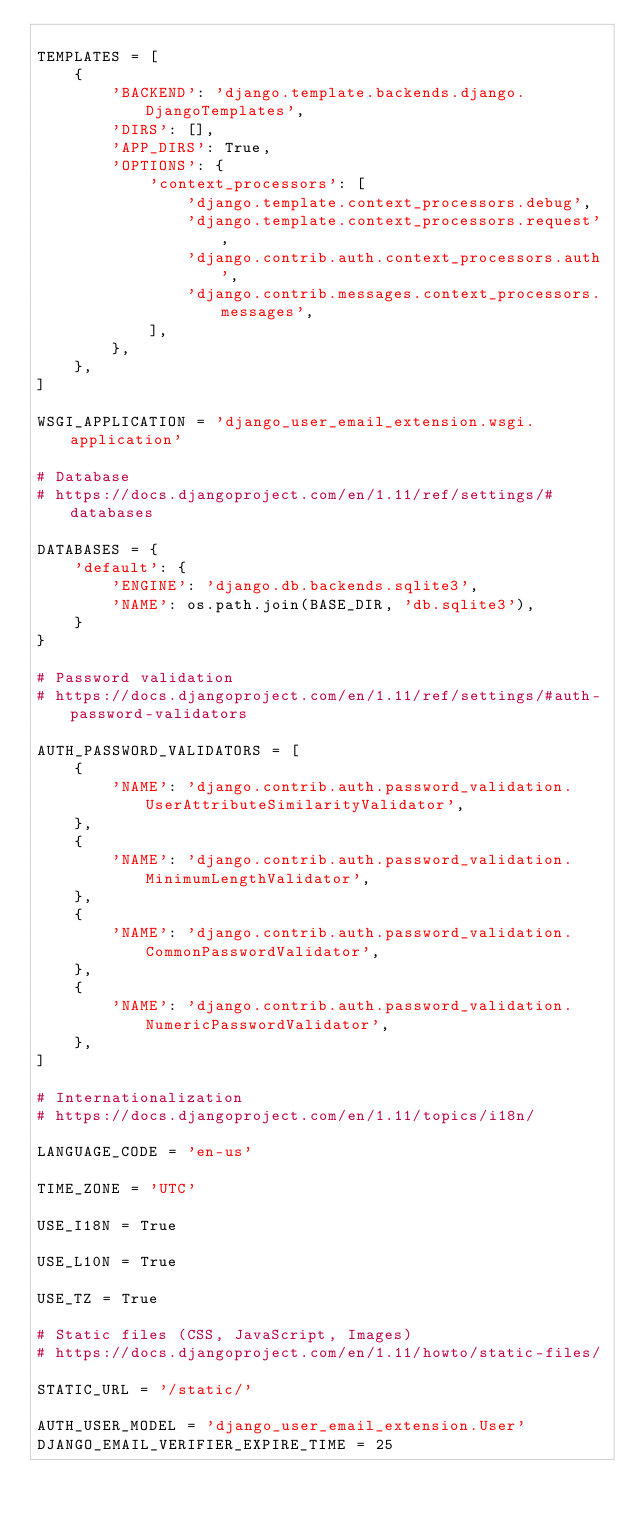<code> <loc_0><loc_0><loc_500><loc_500><_Python_>
TEMPLATES = [
    {
        'BACKEND': 'django.template.backends.django.DjangoTemplates',
        'DIRS': [],
        'APP_DIRS': True,
        'OPTIONS': {
            'context_processors': [
                'django.template.context_processors.debug',
                'django.template.context_processors.request',
                'django.contrib.auth.context_processors.auth',
                'django.contrib.messages.context_processors.messages',
            ],
        },
    },
]

WSGI_APPLICATION = 'django_user_email_extension.wsgi.application'

# Database
# https://docs.djangoproject.com/en/1.11/ref/settings/#databases

DATABASES = {
    'default': {
        'ENGINE': 'django.db.backends.sqlite3',
        'NAME': os.path.join(BASE_DIR, 'db.sqlite3'),
    }
}

# Password validation
# https://docs.djangoproject.com/en/1.11/ref/settings/#auth-password-validators

AUTH_PASSWORD_VALIDATORS = [
    {
        'NAME': 'django.contrib.auth.password_validation.UserAttributeSimilarityValidator',
    },
    {
        'NAME': 'django.contrib.auth.password_validation.MinimumLengthValidator',
    },
    {
        'NAME': 'django.contrib.auth.password_validation.CommonPasswordValidator',
    },
    {
        'NAME': 'django.contrib.auth.password_validation.NumericPasswordValidator',
    },
]

# Internationalization
# https://docs.djangoproject.com/en/1.11/topics/i18n/

LANGUAGE_CODE = 'en-us'

TIME_ZONE = 'UTC'

USE_I18N = True

USE_L10N = True

USE_TZ = True

# Static files (CSS, JavaScript, Images)
# https://docs.djangoproject.com/en/1.11/howto/static-files/

STATIC_URL = '/static/'

AUTH_USER_MODEL = 'django_user_email_extension.User'
DJANGO_EMAIL_VERIFIER_EXPIRE_TIME = 25
</code> 